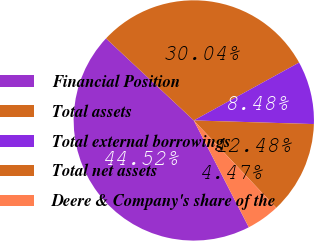<chart> <loc_0><loc_0><loc_500><loc_500><pie_chart><fcel>Financial Position<fcel>Total assets<fcel>Total external borrowings<fcel>Total net assets<fcel>Deere & Company's share of the<nl><fcel>44.52%<fcel>30.04%<fcel>8.48%<fcel>12.48%<fcel>4.47%<nl></chart> 